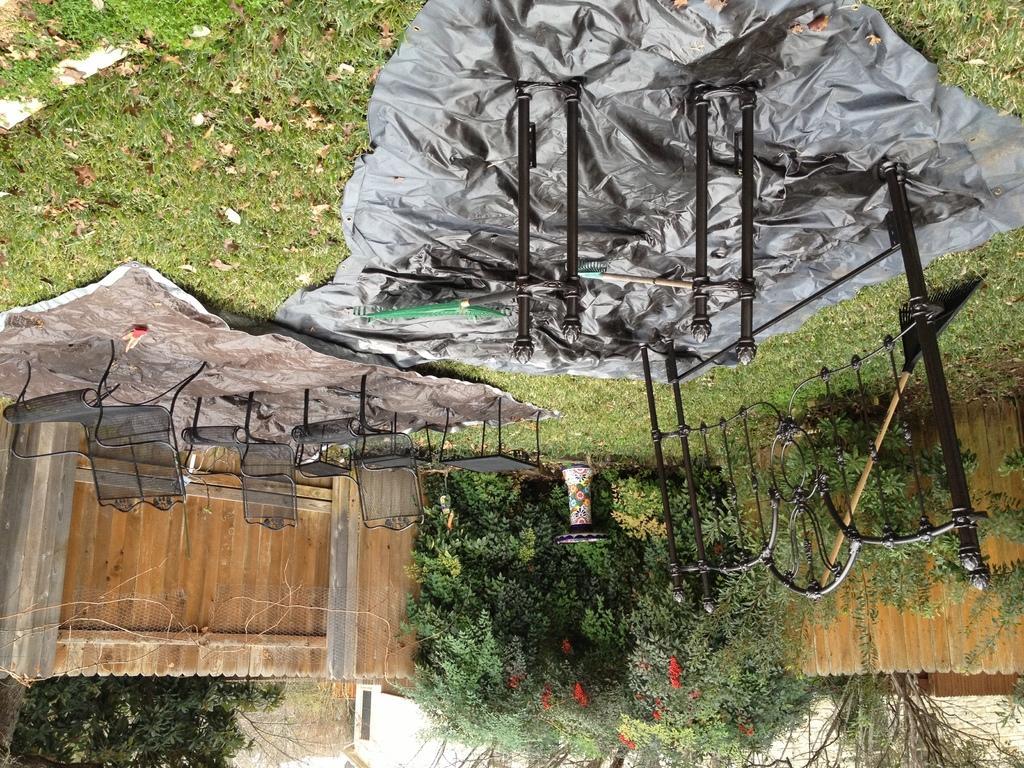Please provide a concise description of this image. In this picture we can see the grey color plastic cover in the grass lawn. On the top we can see the design grill and pipes. Behind there are some metal chairs. In the background there is a wooden boundary wall and some trees. 